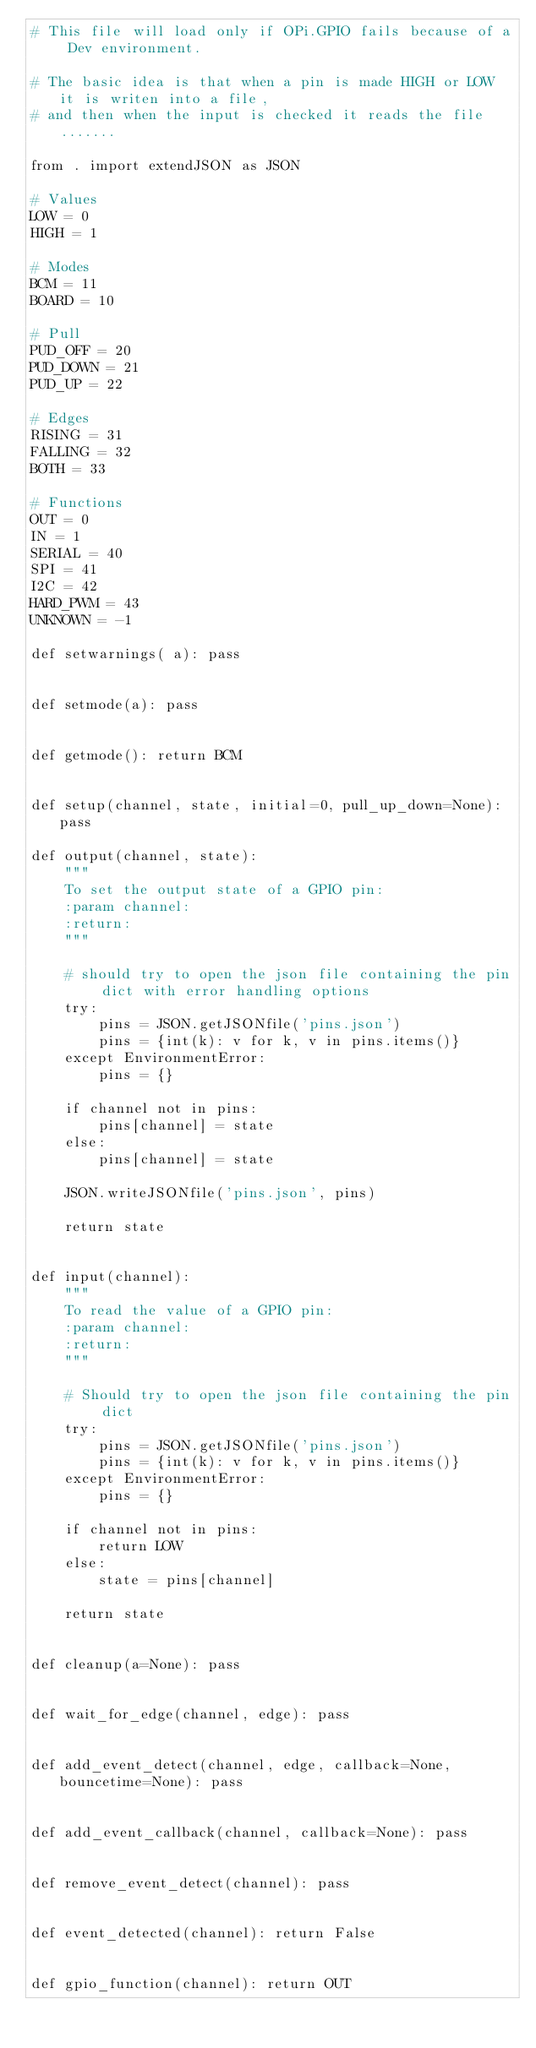Convert code to text. <code><loc_0><loc_0><loc_500><loc_500><_Python_># This file will load only if OPi.GPIO fails because of a Dev environment.

# The basic idea is that when a pin is made HIGH or LOW it is writen into a file,
# and then when the input is checked it reads the file.......

from . import extendJSON as JSON

# Values
LOW = 0
HIGH = 1

# Modes
BCM = 11
BOARD = 10

# Pull
PUD_OFF = 20
PUD_DOWN = 21
PUD_UP = 22

# Edges
RISING = 31
FALLING = 32
BOTH = 33

# Functions
OUT = 0
IN = 1
SERIAL = 40
SPI = 41
I2C = 42
HARD_PWM = 43
UNKNOWN = -1

def setwarnings( a): pass


def setmode(a): pass


def getmode(): return BCM


def setup(channel, state, initial=0, pull_up_down=None): pass

def output(channel, state):
    """
    To set the output state of a GPIO pin:
    :param channel:
    :return:
    """

    # should try to open the json file containing the pin dict with error handling options
    try:
        pins = JSON.getJSONfile('pins.json')
        pins = {int(k): v for k, v in pins.items()}
    except EnvironmentError:
        pins = {}

    if channel not in pins:
        pins[channel] = state
    else:
        pins[channel] = state

    JSON.writeJSONfile('pins.json', pins)

    return state


def input(channel):
    """
    To read the value of a GPIO pin:
    :param channel:
    :return:
    """

    # Should try to open the json file containing the pin dict
    try:
        pins = JSON.getJSONfile('pins.json')
        pins = {int(k): v for k, v in pins.items()}
    except EnvironmentError:
        pins = {}

    if channel not in pins:
        return LOW
    else:
        state = pins[channel]

    return state


def cleanup(a=None): pass


def wait_for_edge(channel, edge): pass


def add_event_detect(channel, edge, callback=None, bouncetime=None): pass


def add_event_callback(channel, callback=None): pass


def remove_event_detect(channel): pass


def event_detected(channel): return False


def gpio_function(channel): return OUT</code> 